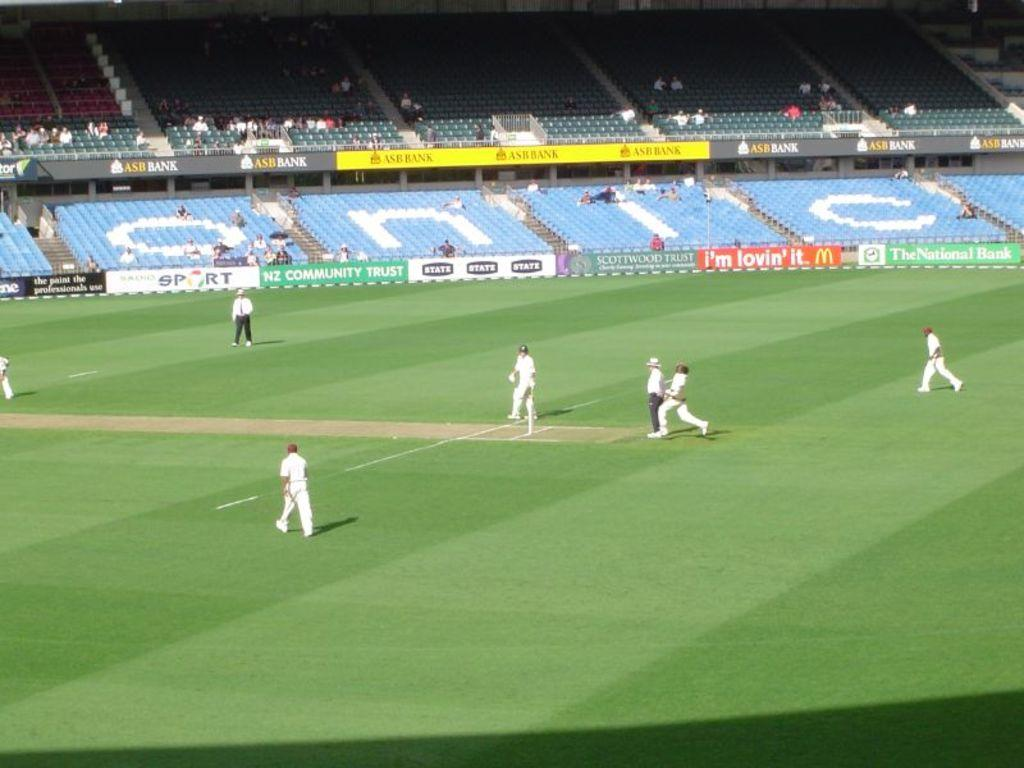<image>
Describe the image concisely. a team getting ready to play on a field sponsored by mcdonalds 